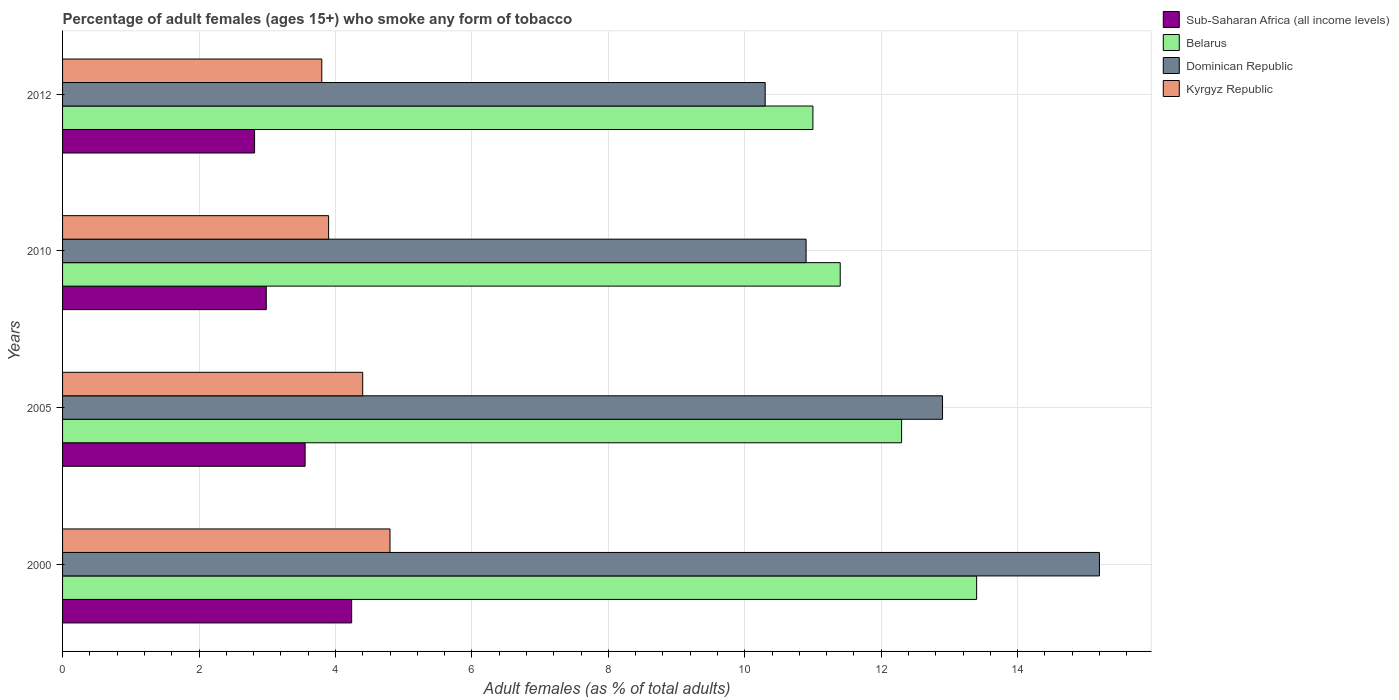Are the number of bars per tick equal to the number of legend labels?
Offer a very short reply. Yes. Are the number of bars on each tick of the Y-axis equal?
Your answer should be very brief. Yes. How many bars are there on the 1st tick from the top?
Ensure brevity in your answer.  4. What is the label of the 2nd group of bars from the top?
Make the answer very short. 2010. What is the percentage of adult females who smoke in Belarus in 2000?
Provide a short and direct response. 13.4. Across all years, what is the maximum percentage of adult females who smoke in Kyrgyz Republic?
Provide a short and direct response. 4.8. Across all years, what is the minimum percentage of adult females who smoke in Dominican Republic?
Provide a short and direct response. 10.3. In which year was the percentage of adult females who smoke in Sub-Saharan Africa (all income levels) minimum?
Your answer should be compact. 2012. What is the total percentage of adult females who smoke in Kyrgyz Republic in the graph?
Your response must be concise. 16.9. What is the difference between the percentage of adult females who smoke in Dominican Republic in 2000 and that in 2005?
Offer a terse response. 2.3. What is the difference between the percentage of adult females who smoke in Dominican Republic in 2000 and the percentage of adult females who smoke in Kyrgyz Republic in 2012?
Your response must be concise. 11.4. What is the average percentage of adult females who smoke in Belarus per year?
Offer a very short reply. 12.03. In the year 2000, what is the difference between the percentage of adult females who smoke in Dominican Republic and percentage of adult females who smoke in Kyrgyz Republic?
Your answer should be compact. 10.4. In how many years, is the percentage of adult females who smoke in Kyrgyz Republic greater than 5.6 %?
Your answer should be compact. 0. What is the ratio of the percentage of adult females who smoke in Belarus in 2005 to that in 2012?
Provide a short and direct response. 1.12. Is the percentage of adult females who smoke in Dominican Republic in 2005 less than that in 2012?
Keep it short and to the point. No. Is the difference between the percentage of adult females who smoke in Dominican Republic in 2005 and 2010 greater than the difference between the percentage of adult females who smoke in Kyrgyz Republic in 2005 and 2010?
Offer a terse response. Yes. What is the difference between the highest and the second highest percentage of adult females who smoke in Dominican Republic?
Provide a short and direct response. 2.3. What is the difference between the highest and the lowest percentage of adult females who smoke in Belarus?
Give a very brief answer. 2.4. Is the sum of the percentage of adult females who smoke in Kyrgyz Republic in 2005 and 2012 greater than the maximum percentage of adult females who smoke in Sub-Saharan Africa (all income levels) across all years?
Make the answer very short. Yes. What does the 1st bar from the top in 2005 represents?
Ensure brevity in your answer.  Kyrgyz Republic. What does the 3rd bar from the bottom in 2010 represents?
Offer a terse response. Dominican Republic. Is it the case that in every year, the sum of the percentage of adult females who smoke in Dominican Republic and percentage of adult females who smoke in Belarus is greater than the percentage of adult females who smoke in Sub-Saharan Africa (all income levels)?
Offer a very short reply. Yes. How many bars are there?
Ensure brevity in your answer.  16. Are all the bars in the graph horizontal?
Your answer should be very brief. Yes. What is the difference between two consecutive major ticks on the X-axis?
Your response must be concise. 2. Does the graph contain grids?
Ensure brevity in your answer.  Yes. Where does the legend appear in the graph?
Your answer should be compact. Top right. How many legend labels are there?
Give a very brief answer. 4. What is the title of the graph?
Make the answer very short. Percentage of adult females (ages 15+) who smoke any form of tobacco. What is the label or title of the X-axis?
Offer a terse response. Adult females (as % of total adults). What is the label or title of the Y-axis?
Your answer should be compact. Years. What is the Adult females (as % of total adults) in Sub-Saharan Africa (all income levels) in 2000?
Keep it short and to the point. 4.24. What is the Adult females (as % of total adults) in Dominican Republic in 2000?
Give a very brief answer. 15.2. What is the Adult females (as % of total adults) of Sub-Saharan Africa (all income levels) in 2005?
Keep it short and to the point. 3.56. What is the Adult females (as % of total adults) of Belarus in 2005?
Ensure brevity in your answer.  12.3. What is the Adult females (as % of total adults) in Kyrgyz Republic in 2005?
Provide a succinct answer. 4.4. What is the Adult females (as % of total adults) in Sub-Saharan Africa (all income levels) in 2010?
Make the answer very short. 2.99. What is the Adult females (as % of total adults) in Dominican Republic in 2010?
Give a very brief answer. 10.9. What is the Adult females (as % of total adults) in Kyrgyz Republic in 2010?
Your answer should be compact. 3.9. What is the Adult females (as % of total adults) of Sub-Saharan Africa (all income levels) in 2012?
Provide a succinct answer. 2.81. What is the Adult females (as % of total adults) in Belarus in 2012?
Your response must be concise. 11. What is the Adult females (as % of total adults) in Dominican Republic in 2012?
Your answer should be compact. 10.3. Across all years, what is the maximum Adult females (as % of total adults) of Sub-Saharan Africa (all income levels)?
Offer a terse response. 4.24. Across all years, what is the maximum Adult females (as % of total adults) of Kyrgyz Republic?
Provide a short and direct response. 4.8. Across all years, what is the minimum Adult females (as % of total adults) in Sub-Saharan Africa (all income levels)?
Ensure brevity in your answer.  2.81. Across all years, what is the minimum Adult females (as % of total adults) of Dominican Republic?
Your answer should be compact. 10.3. Across all years, what is the minimum Adult females (as % of total adults) in Kyrgyz Republic?
Give a very brief answer. 3.8. What is the total Adult females (as % of total adults) in Sub-Saharan Africa (all income levels) in the graph?
Keep it short and to the point. 13.59. What is the total Adult females (as % of total adults) of Belarus in the graph?
Your response must be concise. 48.1. What is the total Adult females (as % of total adults) in Dominican Republic in the graph?
Ensure brevity in your answer.  49.3. What is the difference between the Adult females (as % of total adults) in Sub-Saharan Africa (all income levels) in 2000 and that in 2005?
Your answer should be compact. 0.68. What is the difference between the Adult females (as % of total adults) of Dominican Republic in 2000 and that in 2005?
Your answer should be very brief. 2.3. What is the difference between the Adult females (as % of total adults) of Kyrgyz Republic in 2000 and that in 2005?
Your answer should be compact. 0.4. What is the difference between the Adult females (as % of total adults) of Sub-Saharan Africa (all income levels) in 2000 and that in 2010?
Give a very brief answer. 1.25. What is the difference between the Adult females (as % of total adults) in Sub-Saharan Africa (all income levels) in 2000 and that in 2012?
Your answer should be very brief. 1.42. What is the difference between the Adult females (as % of total adults) in Sub-Saharan Africa (all income levels) in 2005 and that in 2010?
Make the answer very short. 0.57. What is the difference between the Adult females (as % of total adults) in Sub-Saharan Africa (all income levels) in 2005 and that in 2012?
Your answer should be very brief. 0.74. What is the difference between the Adult females (as % of total adults) in Belarus in 2005 and that in 2012?
Offer a very short reply. 1.3. What is the difference between the Adult females (as % of total adults) of Kyrgyz Republic in 2005 and that in 2012?
Provide a short and direct response. 0.6. What is the difference between the Adult females (as % of total adults) of Sub-Saharan Africa (all income levels) in 2010 and that in 2012?
Provide a short and direct response. 0.17. What is the difference between the Adult females (as % of total adults) in Dominican Republic in 2010 and that in 2012?
Give a very brief answer. 0.6. What is the difference between the Adult females (as % of total adults) in Sub-Saharan Africa (all income levels) in 2000 and the Adult females (as % of total adults) in Belarus in 2005?
Offer a very short reply. -8.06. What is the difference between the Adult females (as % of total adults) of Sub-Saharan Africa (all income levels) in 2000 and the Adult females (as % of total adults) of Dominican Republic in 2005?
Keep it short and to the point. -8.66. What is the difference between the Adult females (as % of total adults) in Sub-Saharan Africa (all income levels) in 2000 and the Adult females (as % of total adults) in Kyrgyz Republic in 2005?
Keep it short and to the point. -0.16. What is the difference between the Adult females (as % of total adults) of Belarus in 2000 and the Adult females (as % of total adults) of Kyrgyz Republic in 2005?
Offer a very short reply. 9. What is the difference between the Adult females (as % of total adults) in Sub-Saharan Africa (all income levels) in 2000 and the Adult females (as % of total adults) in Belarus in 2010?
Make the answer very short. -7.16. What is the difference between the Adult females (as % of total adults) in Sub-Saharan Africa (all income levels) in 2000 and the Adult females (as % of total adults) in Dominican Republic in 2010?
Keep it short and to the point. -6.66. What is the difference between the Adult females (as % of total adults) in Sub-Saharan Africa (all income levels) in 2000 and the Adult females (as % of total adults) in Kyrgyz Republic in 2010?
Keep it short and to the point. 0.34. What is the difference between the Adult females (as % of total adults) of Dominican Republic in 2000 and the Adult females (as % of total adults) of Kyrgyz Republic in 2010?
Provide a succinct answer. 11.3. What is the difference between the Adult females (as % of total adults) in Sub-Saharan Africa (all income levels) in 2000 and the Adult females (as % of total adults) in Belarus in 2012?
Keep it short and to the point. -6.76. What is the difference between the Adult females (as % of total adults) of Sub-Saharan Africa (all income levels) in 2000 and the Adult females (as % of total adults) of Dominican Republic in 2012?
Provide a short and direct response. -6.06. What is the difference between the Adult females (as % of total adults) of Sub-Saharan Africa (all income levels) in 2000 and the Adult females (as % of total adults) of Kyrgyz Republic in 2012?
Provide a short and direct response. 0.44. What is the difference between the Adult females (as % of total adults) in Belarus in 2000 and the Adult females (as % of total adults) in Kyrgyz Republic in 2012?
Keep it short and to the point. 9.6. What is the difference between the Adult females (as % of total adults) of Sub-Saharan Africa (all income levels) in 2005 and the Adult females (as % of total adults) of Belarus in 2010?
Your answer should be very brief. -7.84. What is the difference between the Adult females (as % of total adults) in Sub-Saharan Africa (all income levels) in 2005 and the Adult females (as % of total adults) in Dominican Republic in 2010?
Ensure brevity in your answer.  -7.34. What is the difference between the Adult females (as % of total adults) of Sub-Saharan Africa (all income levels) in 2005 and the Adult females (as % of total adults) of Kyrgyz Republic in 2010?
Offer a very short reply. -0.34. What is the difference between the Adult females (as % of total adults) in Belarus in 2005 and the Adult females (as % of total adults) in Dominican Republic in 2010?
Offer a terse response. 1.4. What is the difference between the Adult females (as % of total adults) in Belarus in 2005 and the Adult females (as % of total adults) in Kyrgyz Republic in 2010?
Ensure brevity in your answer.  8.4. What is the difference between the Adult females (as % of total adults) of Dominican Republic in 2005 and the Adult females (as % of total adults) of Kyrgyz Republic in 2010?
Your answer should be compact. 9. What is the difference between the Adult females (as % of total adults) of Sub-Saharan Africa (all income levels) in 2005 and the Adult females (as % of total adults) of Belarus in 2012?
Make the answer very short. -7.44. What is the difference between the Adult females (as % of total adults) of Sub-Saharan Africa (all income levels) in 2005 and the Adult females (as % of total adults) of Dominican Republic in 2012?
Provide a short and direct response. -6.74. What is the difference between the Adult females (as % of total adults) of Sub-Saharan Africa (all income levels) in 2005 and the Adult females (as % of total adults) of Kyrgyz Republic in 2012?
Your response must be concise. -0.24. What is the difference between the Adult females (as % of total adults) of Belarus in 2005 and the Adult females (as % of total adults) of Kyrgyz Republic in 2012?
Your answer should be very brief. 8.5. What is the difference between the Adult females (as % of total adults) of Dominican Republic in 2005 and the Adult females (as % of total adults) of Kyrgyz Republic in 2012?
Give a very brief answer. 9.1. What is the difference between the Adult females (as % of total adults) of Sub-Saharan Africa (all income levels) in 2010 and the Adult females (as % of total adults) of Belarus in 2012?
Offer a terse response. -8.01. What is the difference between the Adult females (as % of total adults) in Sub-Saharan Africa (all income levels) in 2010 and the Adult females (as % of total adults) in Dominican Republic in 2012?
Provide a succinct answer. -7.31. What is the difference between the Adult females (as % of total adults) in Sub-Saharan Africa (all income levels) in 2010 and the Adult females (as % of total adults) in Kyrgyz Republic in 2012?
Your response must be concise. -0.81. What is the difference between the Adult females (as % of total adults) in Belarus in 2010 and the Adult females (as % of total adults) in Dominican Republic in 2012?
Your response must be concise. 1.1. What is the difference between the Adult females (as % of total adults) in Belarus in 2010 and the Adult females (as % of total adults) in Kyrgyz Republic in 2012?
Your response must be concise. 7.6. What is the average Adult females (as % of total adults) in Sub-Saharan Africa (all income levels) per year?
Your answer should be very brief. 3.4. What is the average Adult females (as % of total adults) of Belarus per year?
Your answer should be very brief. 12.03. What is the average Adult females (as % of total adults) in Dominican Republic per year?
Ensure brevity in your answer.  12.32. What is the average Adult females (as % of total adults) in Kyrgyz Republic per year?
Your response must be concise. 4.22. In the year 2000, what is the difference between the Adult females (as % of total adults) in Sub-Saharan Africa (all income levels) and Adult females (as % of total adults) in Belarus?
Give a very brief answer. -9.16. In the year 2000, what is the difference between the Adult females (as % of total adults) in Sub-Saharan Africa (all income levels) and Adult females (as % of total adults) in Dominican Republic?
Make the answer very short. -10.96. In the year 2000, what is the difference between the Adult females (as % of total adults) of Sub-Saharan Africa (all income levels) and Adult females (as % of total adults) of Kyrgyz Republic?
Your answer should be compact. -0.56. In the year 2000, what is the difference between the Adult females (as % of total adults) of Belarus and Adult females (as % of total adults) of Dominican Republic?
Make the answer very short. -1.8. In the year 2005, what is the difference between the Adult females (as % of total adults) in Sub-Saharan Africa (all income levels) and Adult females (as % of total adults) in Belarus?
Your response must be concise. -8.74. In the year 2005, what is the difference between the Adult females (as % of total adults) in Sub-Saharan Africa (all income levels) and Adult females (as % of total adults) in Dominican Republic?
Your answer should be compact. -9.34. In the year 2005, what is the difference between the Adult females (as % of total adults) of Sub-Saharan Africa (all income levels) and Adult females (as % of total adults) of Kyrgyz Republic?
Offer a terse response. -0.84. In the year 2005, what is the difference between the Adult females (as % of total adults) of Belarus and Adult females (as % of total adults) of Dominican Republic?
Make the answer very short. -0.6. In the year 2005, what is the difference between the Adult females (as % of total adults) of Belarus and Adult females (as % of total adults) of Kyrgyz Republic?
Make the answer very short. 7.9. In the year 2005, what is the difference between the Adult females (as % of total adults) in Dominican Republic and Adult females (as % of total adults) in Kyrgyz Republic?
Keep it short and to the point. 8.5. In the year 2010, what is the difference between the Adult females (as % of total adults) in Sub-Saharan Africa (all income levels) and Adult females (as % of total adults) in Belarus?
Your answer should be compact. -8.41. In the year 2010, what is the difference between the Adult females (as % of total adults) in Sub-Saharan Africa (all income levels) and Adult females (as % of total adults) in Dominican Republic?
Your answer should be very brief. -7.91. In the year 2010, what is the difference between the Adult females (as % of total adults) in Sub-Saharan Africa (all income levels) and Adult females (as % of total adults) in Kyrgyz Republic?
Provide a succinct answer. -0.91. In the year 2010, what is the difference between the Adult females (as % of total adults) of Belarus and Adult females (as % of total adults) of Dominican Republic?
Offer a terse response. 0.5. In the year 2012, what is the difference between the Adult females (as % of total adults) of Sub-Saharan Africa (all income levels) and Adult females (as % of total adults) of Belarus?
Provide a succinct answer. -8.19. In the year 2012, what is the difference between the Adult females (as % of total adults) of Sub-Saharan Africa (all income levels) and Adult females (as % of total adults) of Dominican Republic?
Your answer should be very brief. -7.49. In the year 2012, what is the difference between the Adult females (as % of total adults) in Sub-Saharan Africa (all income levels) and Adult females (as % of total adults) in Kyrgyz Republic?
Your answer should be compact. -0.99. What is the ratio of the Adult females (as % of total adults) in Sub-Saharan Africa (all income levels) in 2000 to that in 2005?
Offer a terse response. 1.19. What is the ratio of the Adult females (as % of total adults) of Belarus in 2000 to that in 2005?
Keep it short and to the point. 1.09. What is the ratio of the Adult females (as % of total adults) in Dominican Republic in 2000 to that in 2005?
Provide a succinct answer. 1.18. What is the ratio of the Adult females (as % of total adults) of Kyrgyz Republic in 2000 to that in 2005?
Ensure brevity in your answer.  1.09. What is the ratio of the Adult females (as % of total adults) in Sub-Saharan Africa (all income levels) in 2000 to that in 2010?
Offer a very short reply. 1.42. What is the ratio of the Adult females (as % of total adults) of Belarus in 2000 to that in 2010?
Your answer should be very brief. 1.18. What is the ratio of the Adult females (as % of total adults) of Dominican Republic in 2000 to that in 2010?
Ensure brevity in your answer.  1.39. What is the ratio of the Adult females (as % of total adults) in Kyrgyz Republic in 2000 to that in 2010?
Offer a terse response. 1.23. What is the ratio of the Adult females (as % of total adults) in Sub-Saharan Africa (all income levels) in 2000 to that in 2012?
Your answer should be very brief. 1.51. What is the ratio of the Adult females (as % of total adults) of Belarus in 2000 to that in 2012?
Your answer should be compact. 1.22. What is the ratio of the Adult females (as % of total adults) of Dominican Republic in 2000 to that in 2012?
Keep it short and to the point. 1.48. What is the ratio of the Adult females (as % of total adults) in Kyrgyz Republic in 2000 to that in 2012?
Keep it short and to the point. 1.26. What is the ratio of the Adult females (as % of total adults) in Sub-Saharan Africa (all income levels) in 2005 to that in 2010?
Provide a succinct answer. 1.19. What is the ratio of the Adult females (as % of total adults) of Belarus in 2005 to that in 2010?
Offer a terse response. 1.08. What is the ratio of the Adult females (as % of total adults) of Dominican Republic in 2005 to that in 2010?
Offer a terse response. 1.18. What is the ratio of the Adult females (as % of total adults) in Kyrgyz Republic in 2005 to that in 2010?
Ensure brevity in your answer.  1.13. What is the ratio of the Adult females (as % of total adults) in Sub-Saharan Africa (all income levels) in 2005 to that in 2012?
Your answer should be very brief. 1.26. What is the ratio of the Adult females (as % of total adults) in Belarus in 2005 to that in 2012?
Your response must be concise. 1.12. What is the ratio of the Adult females (as % of total adults) in Dominican Republic in 2005 to that in 2012?
Make the answer very short. 1.25. What is the ratio of the Adult females (as % of total adults) of Kyrgyz Republic in 2005 to that in 2012?
Give a very brief answer. 1.16. What is the ratio of the Adult females (as % of total adults) in Sub-Saharan Africa (all income levels) in 2010 to that in 2012?
Make the answer very short. 1.06. What is the ratio of the Adult females (as % of total adults) in Belarus in 2010 to that in 2012?
Provide a short and direct response. 1.04. What is the ratio of the Adult females (as % of total adults) in Dominican Republic in 2010 to that in 2012?
Provide a succinct answer. 1.06. What is the ratio of the Adult females (as % of total adults) in Kyrgyz Republic in 2010 to that in 2012?
Your response must be concise. 1.03. What is the difference between the highest and the second highest Adult females (as % of total adults) in Sub-Saharan Africa (all income levels)?
Provide a succinct answer. 0.68. What is the difference between the highest and the second highest Adult females (as % of total adults) of Kyrgyz Republic?
Make the answer very short. 0.4. What is the difference between the highest and the lowest Adult females (as % of total adults) of Sub-Saharan Africa (all income levels)?
Make the answer very short. 1.42. What is the difference between the highest and the lowest Adult females (as % of total adults) in Kyrgyz Republic?
Give a very brief answer. 1. 